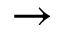<formula> <loc_0><loc_0><loc_500><loc_500>\rightarrow</formula> 